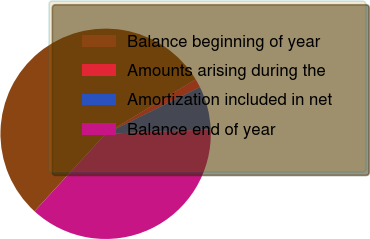Convert chart. <chart><loc_0><loc_0><loc_500><loc_500><pie_chart><fcel>Balance beginning of year<fcel>Amounts arising during the<fcel>Amortization included in net<fcel>Balance end of year<nl><fcel>54.52%<fcel>1.33%<fcel>6.65%<fcel>37.49%<nl></chart> 